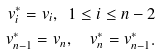<formula> <loc_0><loc_0><loc_500><loc_500>v ^ { * } _ { i } = v _ { i } , \ 1 \leq i \leq n - 2 \\ v ^ { * } _ { n - 1 } = v _ { n } , \quad v ^ { * } _ { n } = v ^ { * } _ { n - 1 } .</formula> 